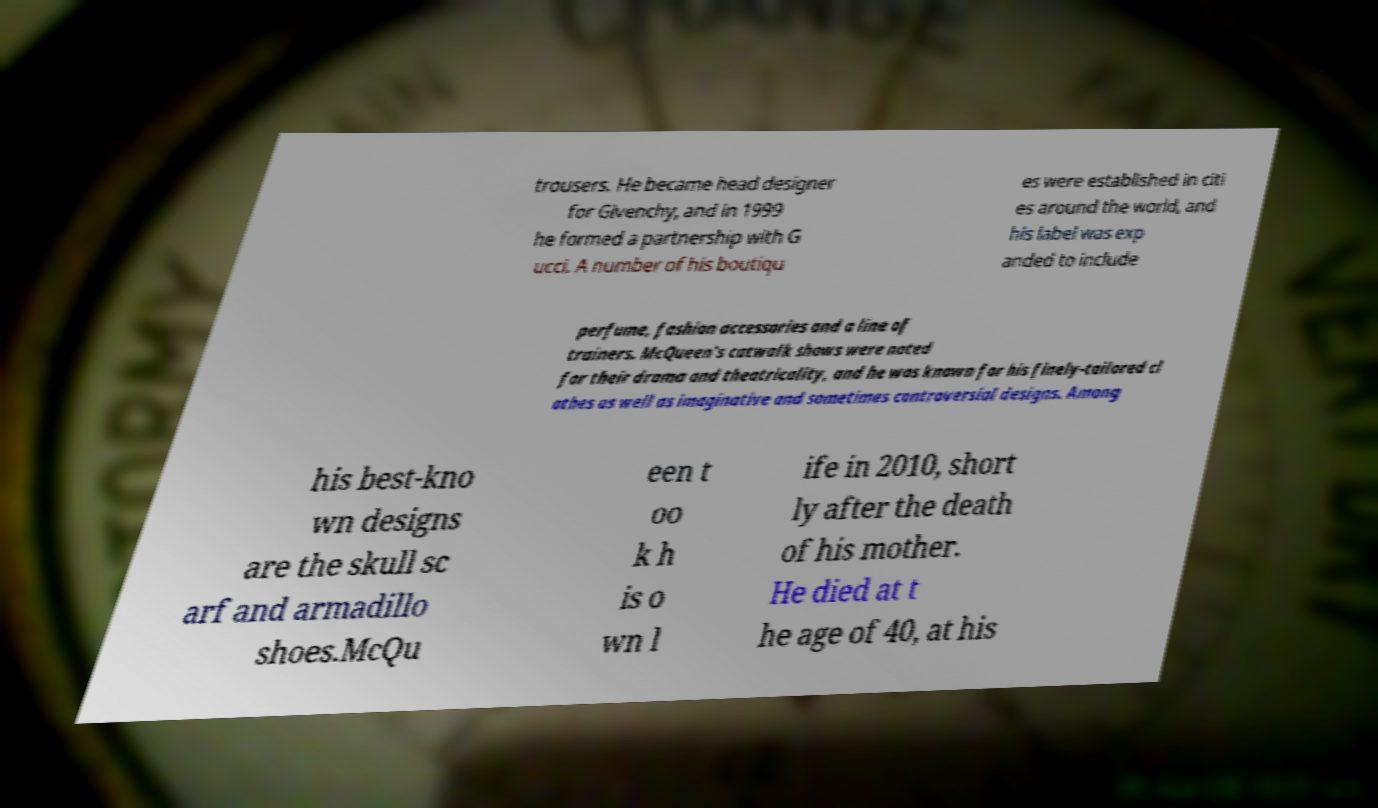Could you assist in decoding the text presented in this image and type it out clearly? trousers. He became head designer for Givenchy, and in 1999 he formed a partnership with G ucci. A number of his boutiqu es were established in citi es around the world, and his label was exp anded to include perfume, fashion accessories and a line of trainers. McQueen's catwalk shows were noted for their drama and theatricality, and he was known for his finely-tailored cl othes as well as imaginative and sometimes controversial designs. Among his best-kno wn designs are the skull sc arf and armadillo shoes.McQu een t oo k h is o wn l ife in 2010, short ly after the death of his mother. He died at t he age of 40, at his 